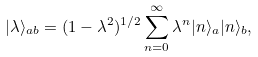<formula> <loc_0><loc_0><loc_500><loc_500>| \lambda \rangle _ { a b } = ( 1 - \lambda ^ { 2 } ) ^ { 1 / 2 } \sum _ { n = 0 } ^ { \infty } \lambda ^ { n } | n \rangle _ { a } | n \rangle _ { b } ,</formula> 